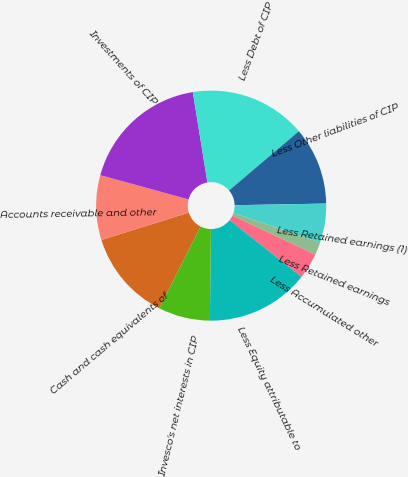<chart> <loc_0><loc_0><loc_500><loc_500><pie_chart><fcel>Cash and cash equivalents of<fcel>Accounts receivable and other<fcel>Investments of CIP<fcel>Less Debt of CIP<fcel>Less Other liabilities of CIP<fcel>Less Retained earnings (1)<fcel>Less Retained earnings<fcel>Less Accumulated other<fcel>Less Equity attributable to<fcel>Invesco's net interests in CIP<nl><fcel>12.73%<fcel>9.09%<fcel>18.18%<fcel>16.36%<fcel>10.91%<fcel>5.46%<fcel>1.82%<fcel>3.64%<fcel>14.54%<fcel>7.27%<nl></chart> 